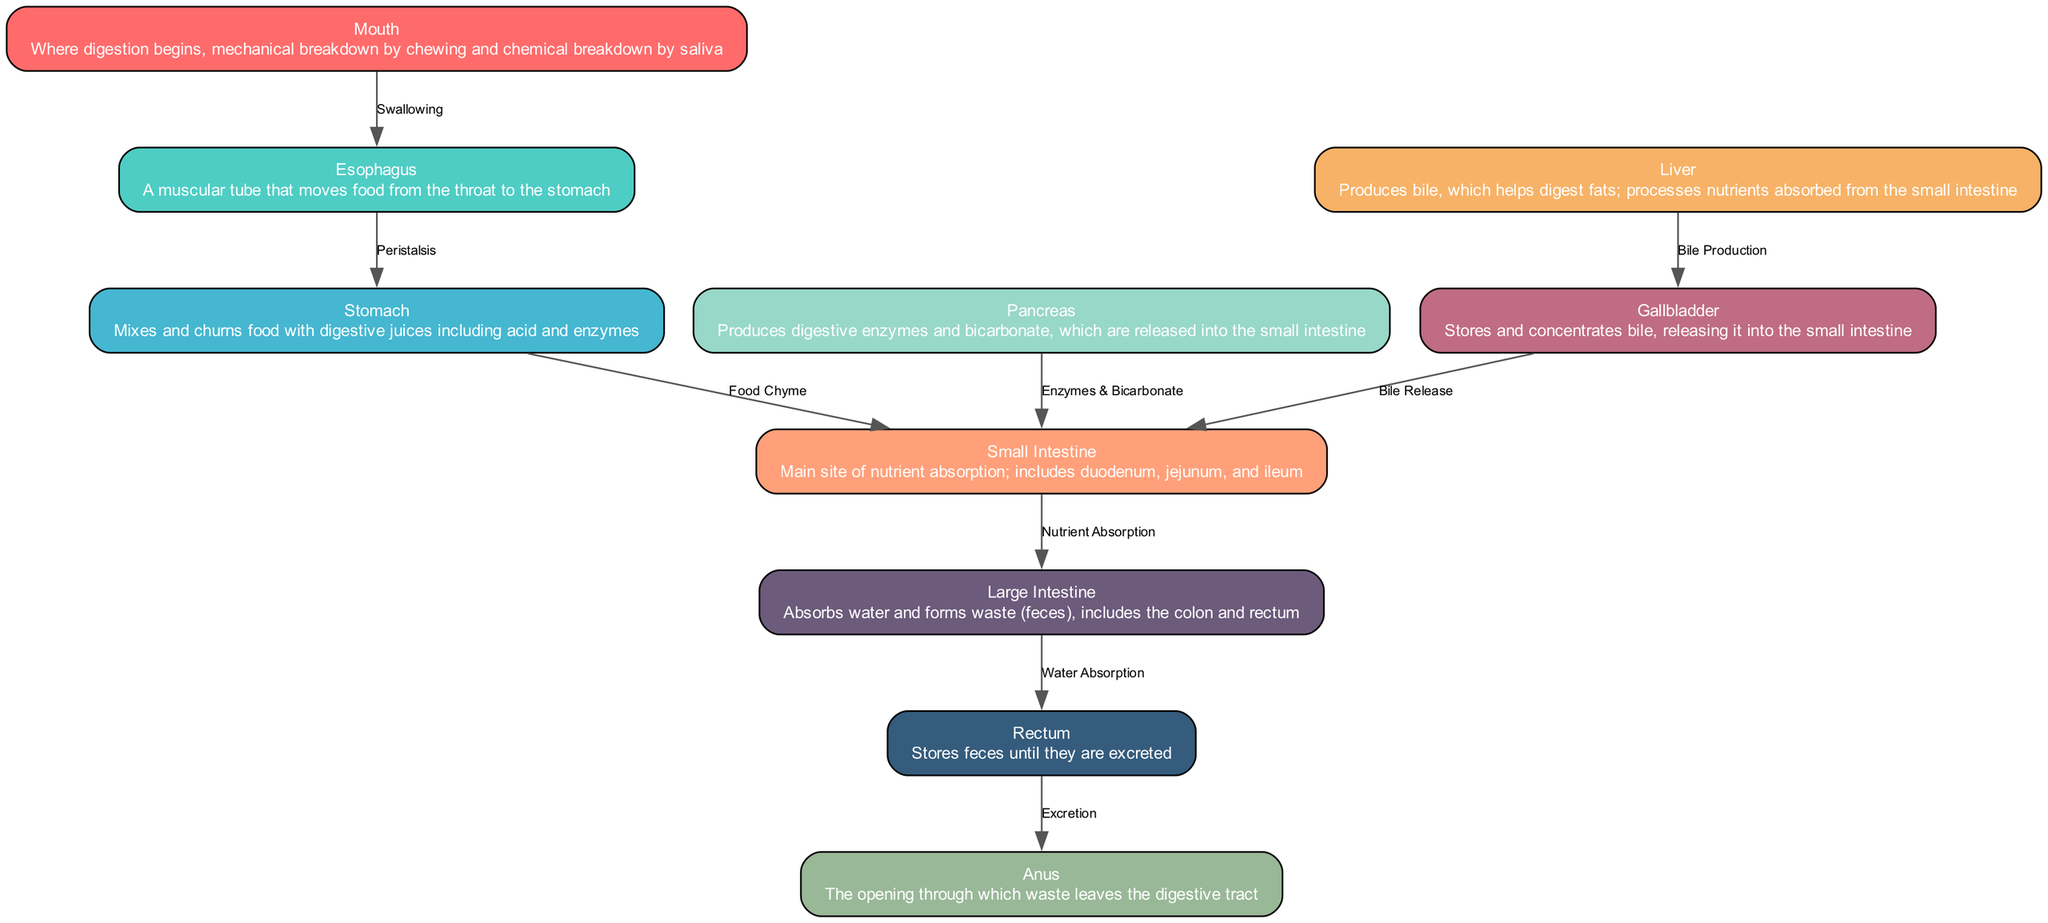What organ is responsible for the chemical breakdown of food? The diagram shows that the stomach mixes and churns food with digestive juices, which are critical for chemical breakdown.
Answer: Stomach How many nodes are in the digestive system diagram? By counting the nodes listed in the data, we find there are ten distinct organs represented in the diagram.
Answer: 10 What connects the mouth and esophagus? The edge labeled "Swallowing" directly connects the mouth to the esophagus, indicating the action that moves food from one to the other.
Answer: Swallowing Which organ absorbs water? The large intestine is directly indicated as the organ responsible for absorbing water and forming waste.
Answer: Large Intestine What organ produces bile? According to the diagram, the liver has the function of producing bile, which is essential for fat digestion.
Answer: Liver What is the function of the pancreas in the digestive system? The pancreas is described as producing digestive enzymes and bicarbonate, which are released into the small intestine for further digestion.
Answer: Produces digestive enzymes and bicarbonate What process does the rectum perform? The diagram indicates that the rectum stores feces until they are excreted through the anus, making it a key location in waste elimination.
Answer: Stores feces Which two organs are connected by the edge labeled "Nutrient Absorption"? The edge labeled "Nutrient Absorption" connects the small intestine to the large intestine, implying that nutrients are absorbed in this part of the digestive process.
Answer: Small Intestine and Large Intestine What happens to the bile produced by the liver? The liver's bile production is directed to the gallbladder for storage, and the gallbladder subsequently releases this bile into the small intestine for digestion.
Answer: Stored in the gallbladder and released into the small intestine 